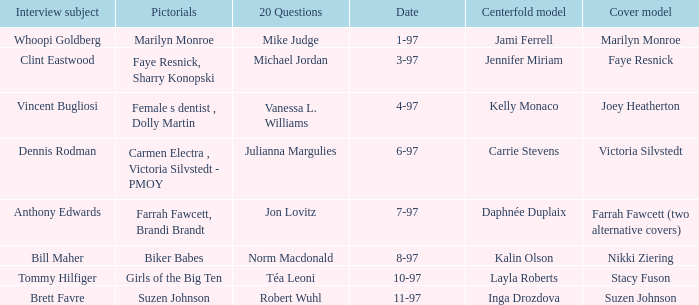What is the name of the cover model on 3-97? Faye Resnick. 